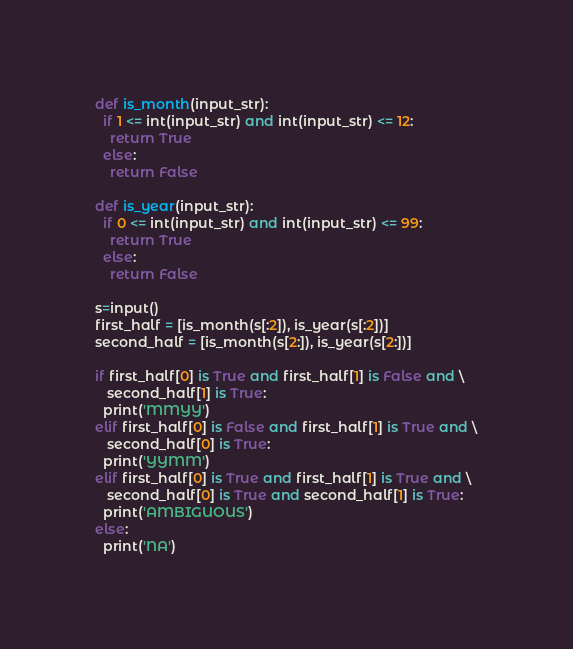<code> <loc_0><loc_0><loc_500><loc_500><_Python_>def is_month(input_str):
  if 1 <= int(input_str) and int(input_str) <= 12:
    return True
  else:
    return False
    
def is_year(input_str):
  if 0 <= int(input_str) and int(input_str) <= 99:
    return True
  else:
    return False

s=input()
first_half = [is_month(s[:2]), is_year(s[:2])]
second_half = [is_month(s[2:]), is_year(s[2:])]

if first_half[0] is True and first_half[1] is False and \
   second_half[1] is True:
  print('MMYY')
elif first_half[0] is False and first_half[1] is True and \
   second_half[0] is True:
  print('YYMM')
elif first_half[0] is True and first_half[1] is True and \
   second_half[0] is True and second_half[1] is True:
  print('AMBIGUOUS')
else:
  print('NA')</code> 